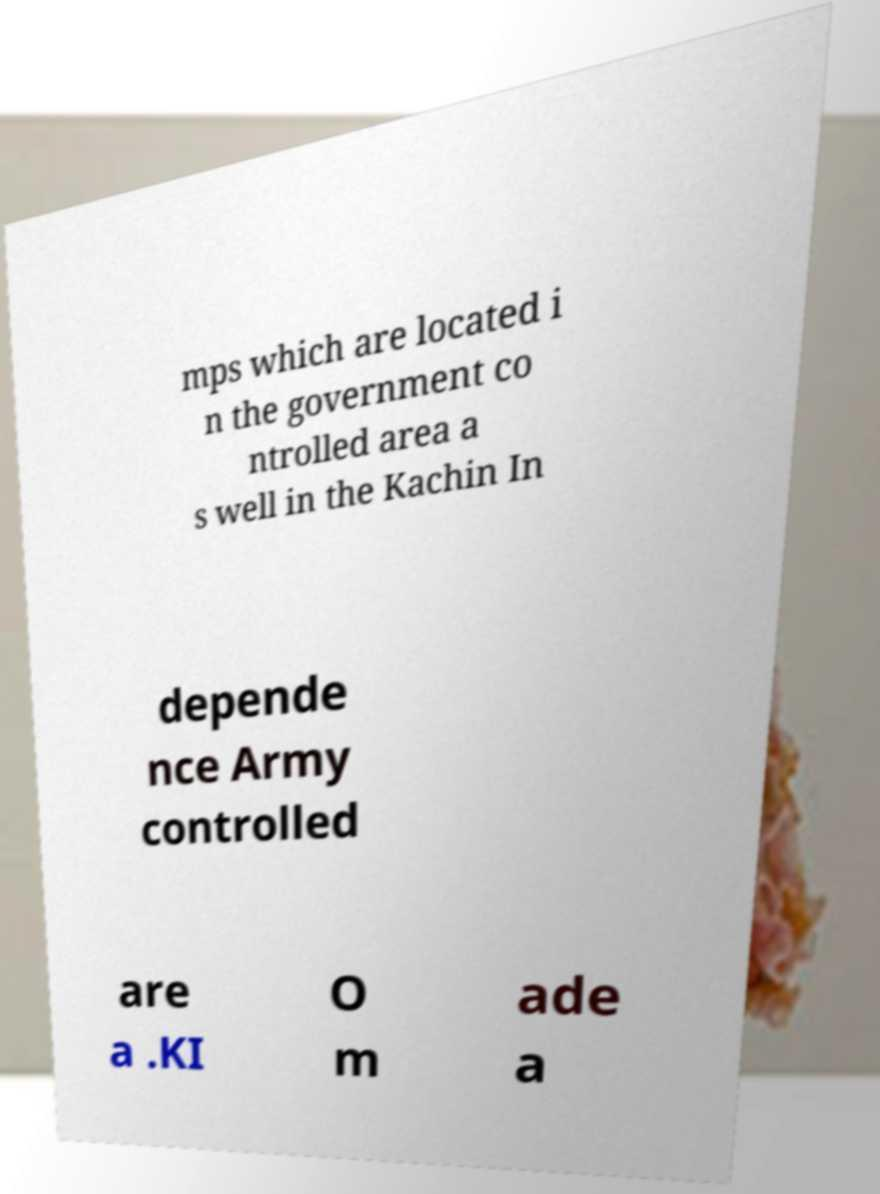For documentation purposes, I need the text within this image transcribed. Could you provide that? mps which are located i n the government co ntrolled area a s well in the Kachin In depende nce Army controlled are a .KI O m ade a 